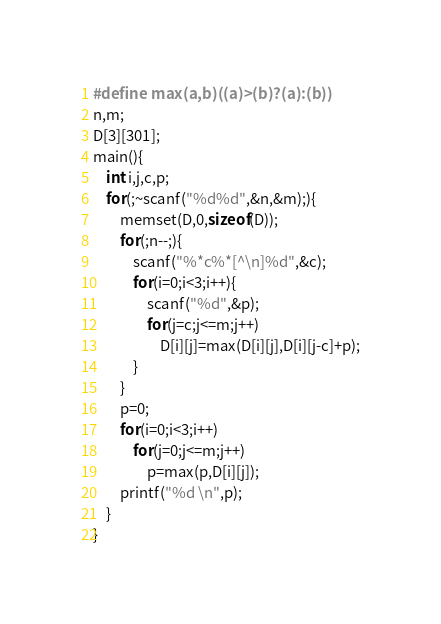<code> <loc_0><loc_0><loc_500><loc_500><_C_>#define max(a,b)((a)>(b)?(a):(b))
n,m;
D[3][301];
main(){
	int i,j,c,p;
	for(;~scanf("%d%d",&n,&m);){
		memset(D,0,sizeof(D));
		for(;n--;){
			scanf("%*c%*[^\n]%d",&c);
			for(i=0;i<3;i++){
				scanf("%d",&p);
				for(j=c;j<=m;j++)
					D[i][j]=max(D[i][j],D[i][j-c]+p);
			}
		}
		p=0;
		for(i=0;i<3;i++)
			for(j=0;j<=m;j++)
				p=max(p,D[i][j]);
		printf("%d \n",p);
	}
}</code> 